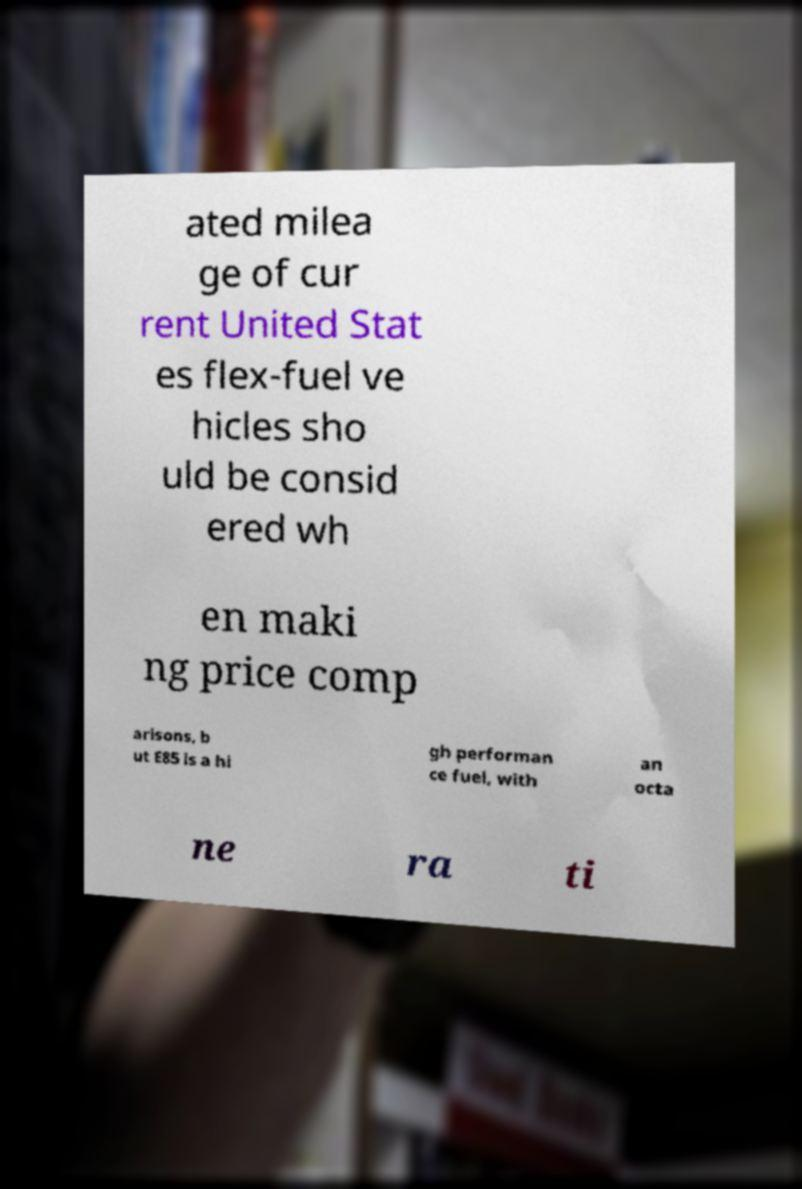Please read and relay the text visible in this image. What does it say? ated milea ge of cur rent United Stat es flex-fuel ve hicles sho uld be consid ered wh en maki ng price comp arisons, b ut E85 is a hi gh performan ce fuel, with an octa ne ra ti 